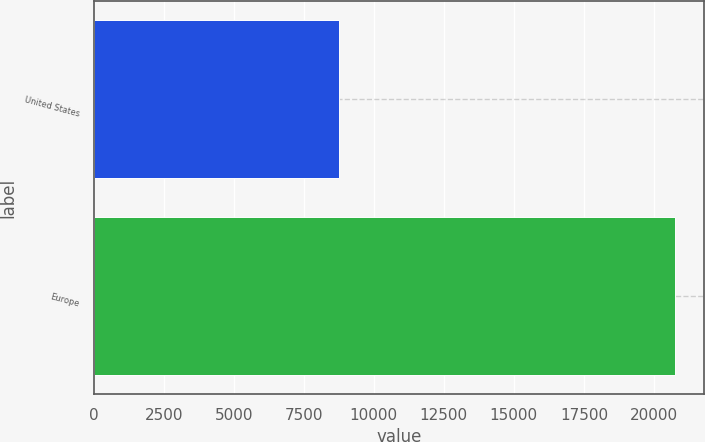Convert chart. <chart><loc_0><loc_0><loc_500><loc_500><bar_chart><fcel>United States<fcel>Europe<nl><fcel>8772<fcel>20758<nl></chart> 